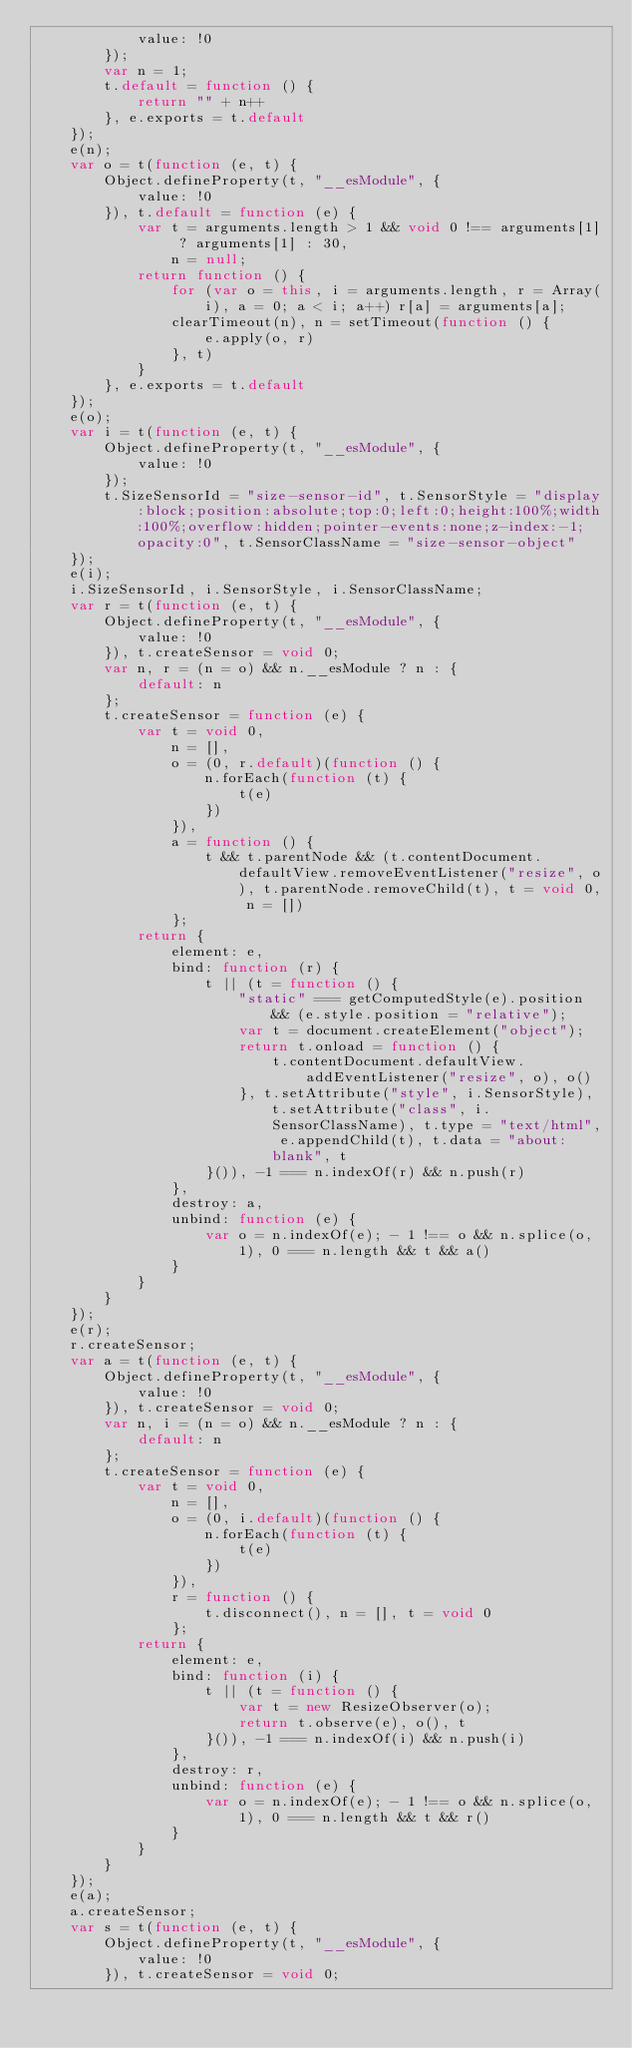Convert code to text. <code><loc_0><loc_0><loc_500><loc_500><_JavaScript_>            value: !0
        });
        var n = 1;
        t.default = function () {
            return "" + n++
        }, e.exports = t.default
    });
    e(n);
    var o = t(function (e, t) {
        Object.defineProperty(t, "__esModule", {
            value: !0
        }), t.default = function (e) {
            var t = arguments.length > 1 && void 0 !== arguments[1] ? arguments[1] : 30,
                n = null;
            return function () {
                for (var o = this, i = arguments.length, r = Array(i), a = 0; a < i; a++) r[a] = arguments[a];
                clearTimeout(n), n = setTimeout(function () {
                    e.apply(o, r)
                }, t)
            }
        }, e.exports = t.default
    });
    e(o);
    var i = t(function (e, t) {
        Object.defineProperty(t, "__esModule", {
            value: !0
        });
        t.SizeSensorId = "size-sensor-id", t.SensorStyle = "display:block;position:absolute;top:0;left:0;height:100%;width:100%;overflow:hidden;pointer-events:none;z-index:-1;opacity:0", t.SensorClassName = "size-sensor-object"
    });
    e(i);
    i.SizeSensorId, i.SensorStyle, i.SensorClassName;
    var r = t(function (e, t) {
        Object.defineProperty(t, "__esModule", {
            value: !0
        }), t.createSensor = void 0;
        var n, r = (n = o) && n.__esModule ? n : {
            default: n
        };
        t.createSensor = function (e) {
            var t = void 0,
                n = [],
                o = (0, r.default)(function () {
                    n.forEach(function (t) {
                        t(e)
                    })
                }),
                a = function () {
                    t && t.parentNode && (t.contentDocument.defaultView.removeEventListener("resize", o), t.parentNode.removeChild(t), t = void 0, n = [])
                };
            return {
                element: e,
                bind: function (r) {
                    t || (t = function () {
                        "static" === getComputedStyle(e).position && (e.style.position = "relative");
                        var t = document.createElement("object");
                        return t.onload = function () {
                            t.contentDocument.defaultView.addEventListener("resize", o), o()
                        }, t.setAttribute("style", i.SensorStyle), t.setAttribute("class", i.SensorClassName), t.type = "text/html", e.appendChild(t), t.data = "about:blank", t
                    }()), -1 === n.indexOf(r) && n.push(r)
                },
                destroy: a,
                unbind: function (e) {
                    var o = n.indexOf(e); - 1 !== o && n.splice(o, 1), 0 === n.length && t && a()
                }
            }
        }
    });
    e(r);
    r.createSensor;
    var a = t(function (e, t) {
        Object.defineProperty(t, "__esModule", {
            value: !0
        }), t.createSensor = void 0;
        var n, i = (n = o) && n.__esModule ? n : {
            default: n
        };
        t.createSensor = function (e) {
            var t = void 0,
                n = [],
                o = (0, i.default)(function () {
                    n.forEach(function (t) {
                        t(e)
                    })
                }),
                r = function () {
                    t.disconnect(), n = [], t = void 0
                };
            return {
                element: e,
                bind: function (i) {
                    t || (t = function () {
                        var t = new ResizeObserver(o);
                        return t.observe(e), o(), t
                    }()), -1 === n.indexOf(i) && n.push(i)
                },
                destroy: r,
                unbind: function (e) {
                    var o = n.indexOf(e); - 1 !== o && n.splice(o, 1), 0 === n.length && t && r()
                }
            }
        }
    });
    e(a);
    a.createSensor;
    var s = t(function (e, t) {
        Object.defineProperty(t, "__esModule", {
            value: !0
        }), t.createSensor = void 0;</code> 